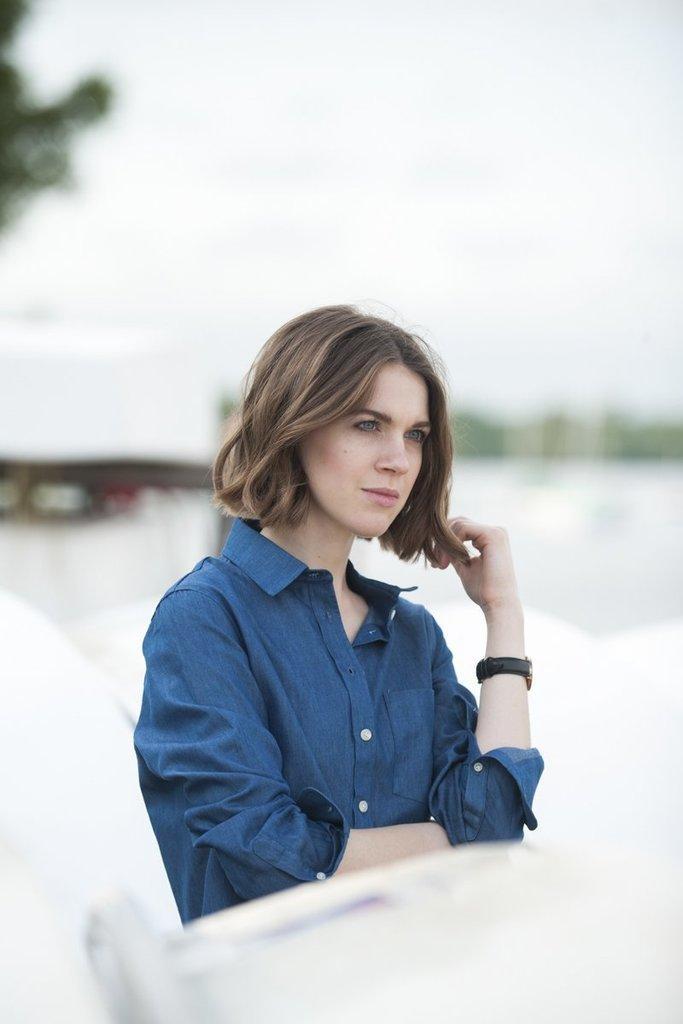Could you give a brief overview of what you see in this image? In this picture I can see a woman, and there is blur background. 